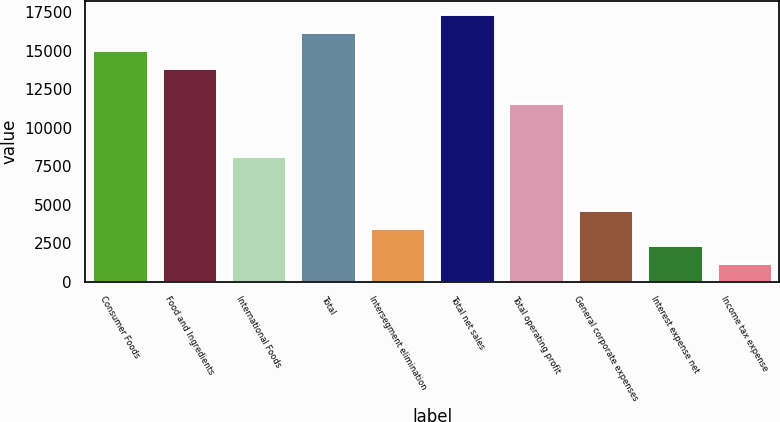<chart> <loc_0><loc_0><loc_500><loc_500><bar_chart><fcel>Consumer Foods<fcel>Food and Ingredients<fcel>International Foods<fcel>Total<fcel>Intersegment elimination<fcel>Total net sales<fcel>Total operating profit<fcel>General corporate expenses<fcel>Interest expense net<fcel>Income tax expense<nl><fcel>15072.5<fcel>13916.9<fcel>8138.9<fcel>16228.1<fcel>3516.5<fcel>17383.7<fcel>11605.7<fcel>4672.1<fcel>2360.9<fcel>1205.3<nl></chart> 